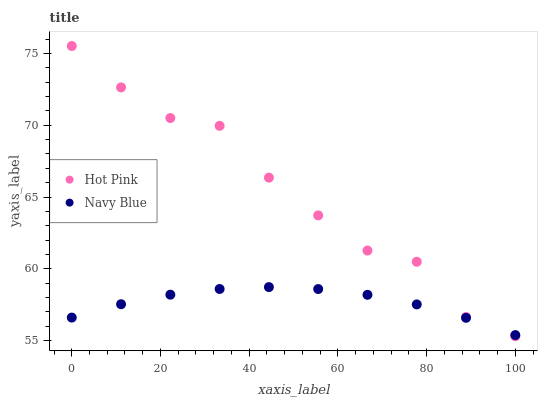Does Navy Blue have the minimum area under the curve?
Answer yes or no. Yes. Does Hot Pink have the maximum area under the curve?
Answer yes or no. Yes. Does Hot Pink have the minimum area under the curve?
Answer yes or no. No. Is Navy Blue the smoothest?
Answer yes or no. Yes. Is Hot Pink the roughest?
Answer yes or no. Yes. Is Hot Pink the smoothest?
Answer yes or no. No. Does Hot Pink have the lowest value?
Answer yes or no. Yes. Does Hot Pink have the highest value?
Answer yes or no. Yes. Does Hot Pink intersect Navy Blue?
Answer yes or no. Yes. Is Hot Pink less than Navy Blue?
Answer yes or no. No. Is Hot Pink greater than Navy Blue?
Answer yes or no. No. 